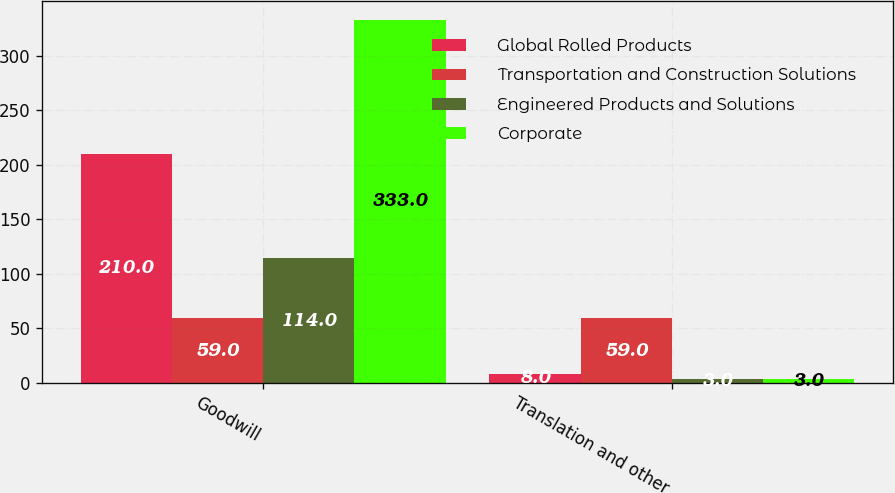Convert chart. <chart><loc_0><loc_0><loc_500><loc_500><stacked_bar_chart><ecel><fcel>Goodwill<fcel>Translation and other<nl><fcel>Global Rolled Products<fcel>210<fcel>8<nl><fcel>Transportation and Construction Solutions<fcel>59<fcel>59<nl><fcel>Engineered Products and Solutions<fcel>114<fcel>3<nl><fcel>Corporate<fcel>333<fcel>3<nl></chart> 